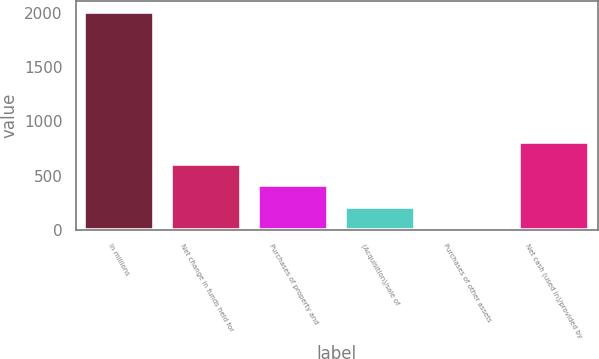<chart> <loc_0><loc_0><loc_500><loc_500><bar_chart><fcel>In millions<fcel>Net change in funds held for<fcel>Purchases of property and<fcel>(Acquisition)/sale of<fcel>Purchases of other assets<fcel>Net cash (used in)/provided by<nl><fcel>2010<fcel>611.33<fcel>411.52<fcel>211.71<fcel>11.9<fcel>811.14<nl></chart> 